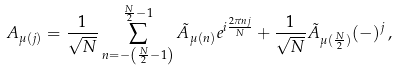<formula> <loc_0><loc_0><loc_500><loc_500>A _ { \mu ( j ) } = \frac { 1 } { \sqrt { N } } \sum _ { n = - \left ( \frac { N } { 2 } - 1 \right ) } ^ { \frac { N } { 2 } - 1 } \tilde { A } _ { \mu ( n ) } e ^ { i \frac { 2 \pi n j } { N } } + \frac { 1 } { \sqrt { N } } \tilde { A } _ { \mu ( \frac { N } { 2 } ) } ( - ) ^ { j } \, ,</formula> 